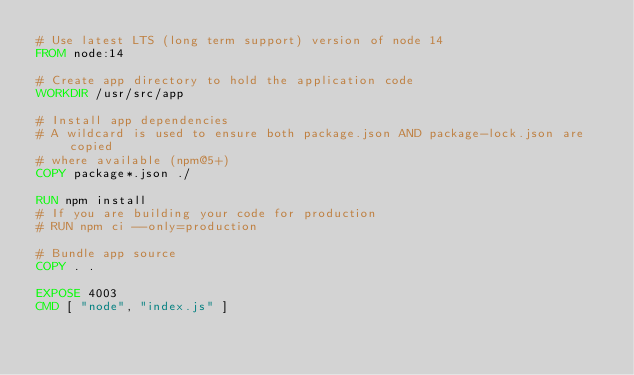Convert code to text. <code><loc_0><loc_0><loc_500><loc_500><_Dockerfile_># Use latest LTS (long term support) version of node 14
FROM node:14

# Create app directory to hold the application code
WORKDIR /usr/src/app

# Install app dependencies
# A wildcard is used to ensure both package.json AND package-lock.json are copied
# where available (npm@5+)
COPY package*.json ./

RUN npm install
# If you are building your code for production
# RUN npm ci --only=production

# Bundle app source
COPY . .

EXPOSE 4003
CMD [ "node", "index.js" ]
</code> 